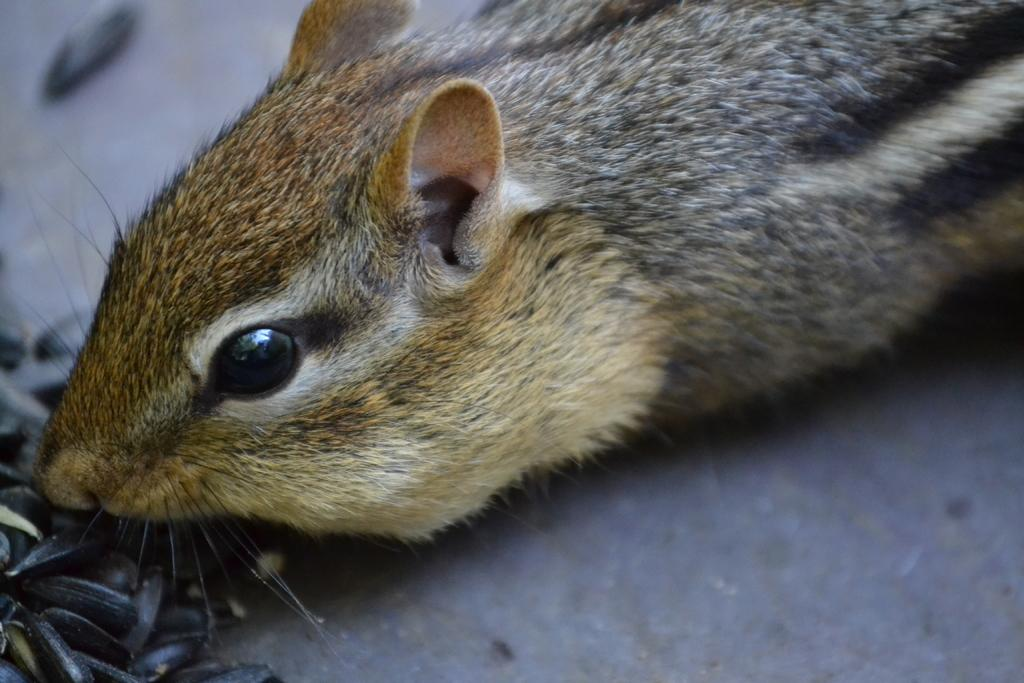What animal is in the center of the image? There is a squirrel in the center of the image. What can be found at the bottom side of the image? There are seeds in the bottom side of the image. How many stamps are on the squirrel's tail in the image? There are no stamps present in the image, as it features a squirrel and seeds. 